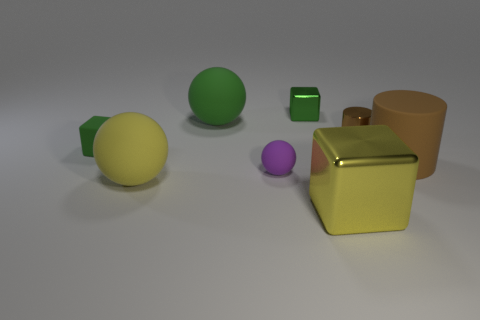Is there any other thing of the same color as the rubber cube?
Offer a terse response. Yes. Do the big rubber cylinder and the small metallic cylinder have the same color?
Keep it short and to the point. Yes. What color is the block that is made of the same material as the small purple ball?
Offer a very short reply. Green. Is the material of the brown cylinder in front of the matte cube the same as the small green block that is on the right side of the large yellow matte ball?
Provide a short and direct response. No. What size is the matte object that is the same color as the rubber cube?
Offer a very short reply. Large. There is a ball behind the small rubber block; what material is it?
Provide a succinct answer. Rubber. Do the green thing to the right of the big green matte thing and the large object that is behind the brown metallic cylinder have the same shape?
Provide a short and direct response. No. There is a tiny cylinder that is the same color as the big cylinder; what is its material?
Your answer should be compact. Metal. Are any big purple metallic objects visible?
Ensure brevity in your answer.  No. There is another brown thing that is the same shape as the large brown thing; what is it made of?
Offer a very short reply. Metal. 